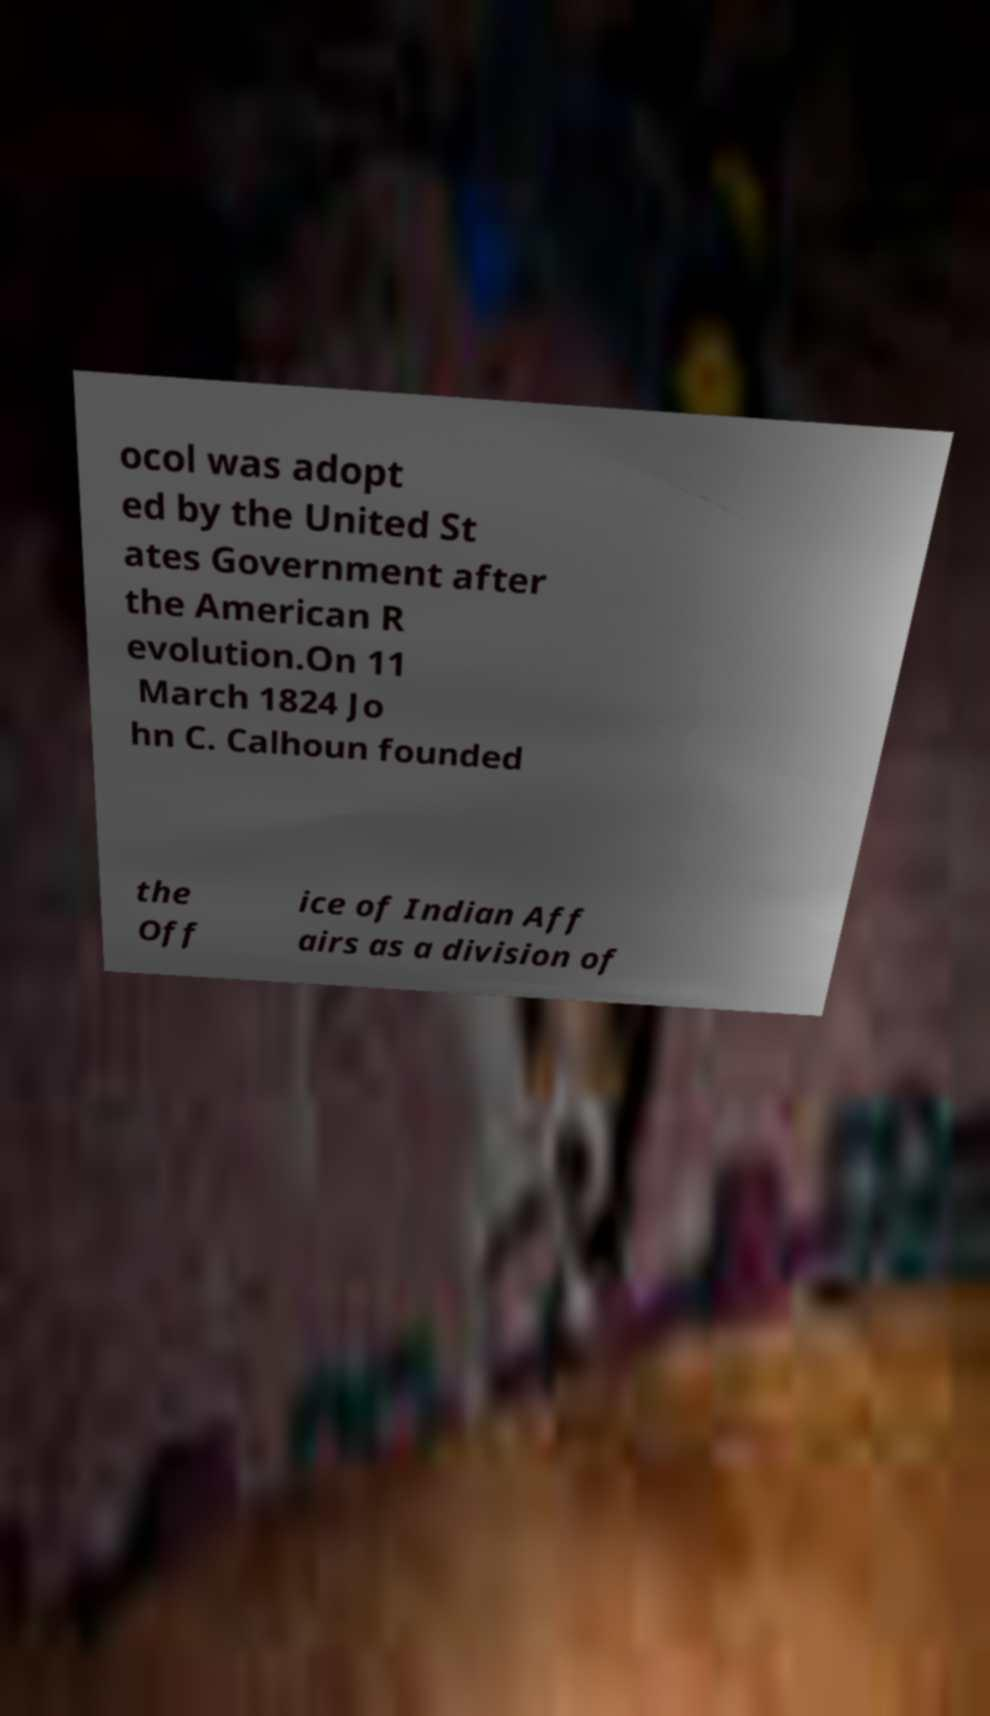What messages or text are displayed in this image? I need them in a readable, typed format. ocol was adopt ed by the United St ates Government after the American R evolution.On 11 March 1824 Jo hn C. Calhoun founded the Off ice of Indian Aff airs as a division of 